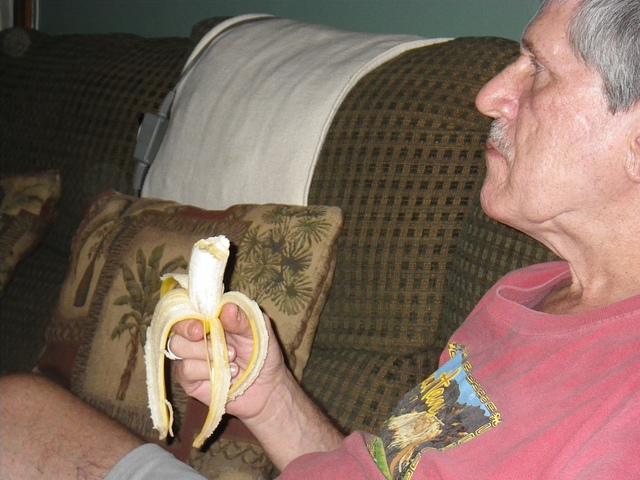What is the man eating?
Quick response, please. Banana. What color is the man's hair?
Concise answer only. Gray. Is there an electrical device in the picture?
Quick response, please. No. 